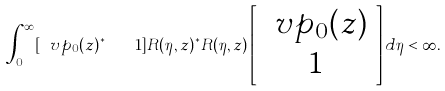Convert formula to latex. <formula><loc_0><loc_0><loc_500><loc_500>\int _ { 0 } ^ { \infty } [ \ v p _ { 0 } ( z ) ^ { * } \quad 1 ] R ( \eta , z ) ^ { * } R ( \eta , z ) \left [ \begin{array} { c } \ v p _ { 0 } ( z ) \\ 1 \end{array} \right ] d \eta < \infty .</formula> 